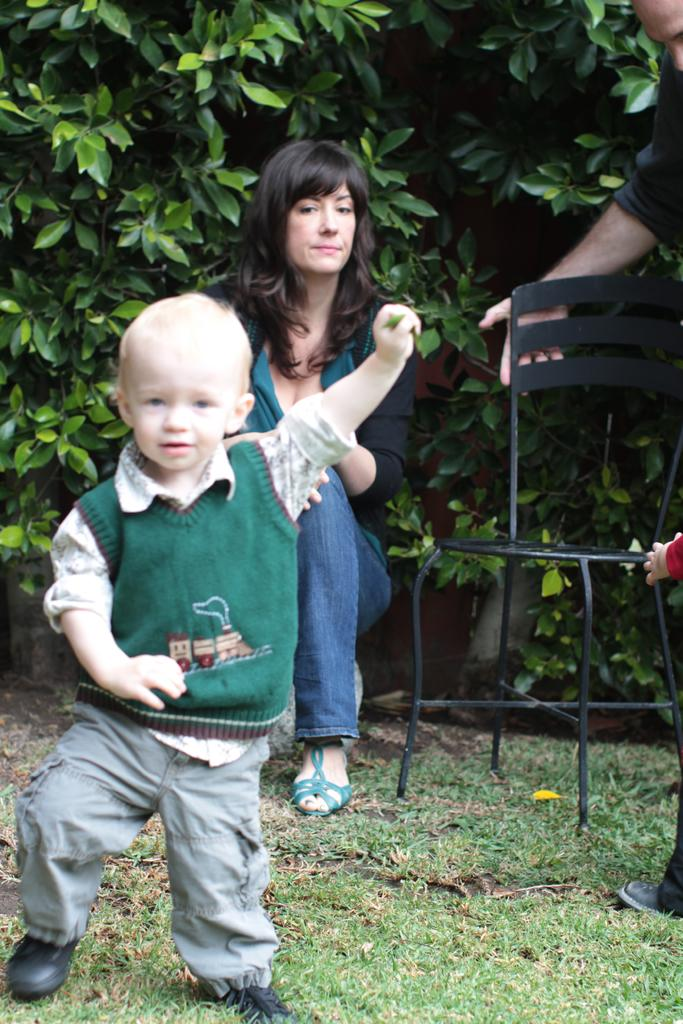Who or what can be seen in the image? There are people in the image. What piece of furniture is present in the image? There is a chair in the image. What type of surface is visible under the people's feet? The ground is visible in the image and has grass. What can be seen in the distance behind the people? There are plants in the background of the image. What type of bird is perched on the chair in the image? There is no bird present on the chair in the image. 